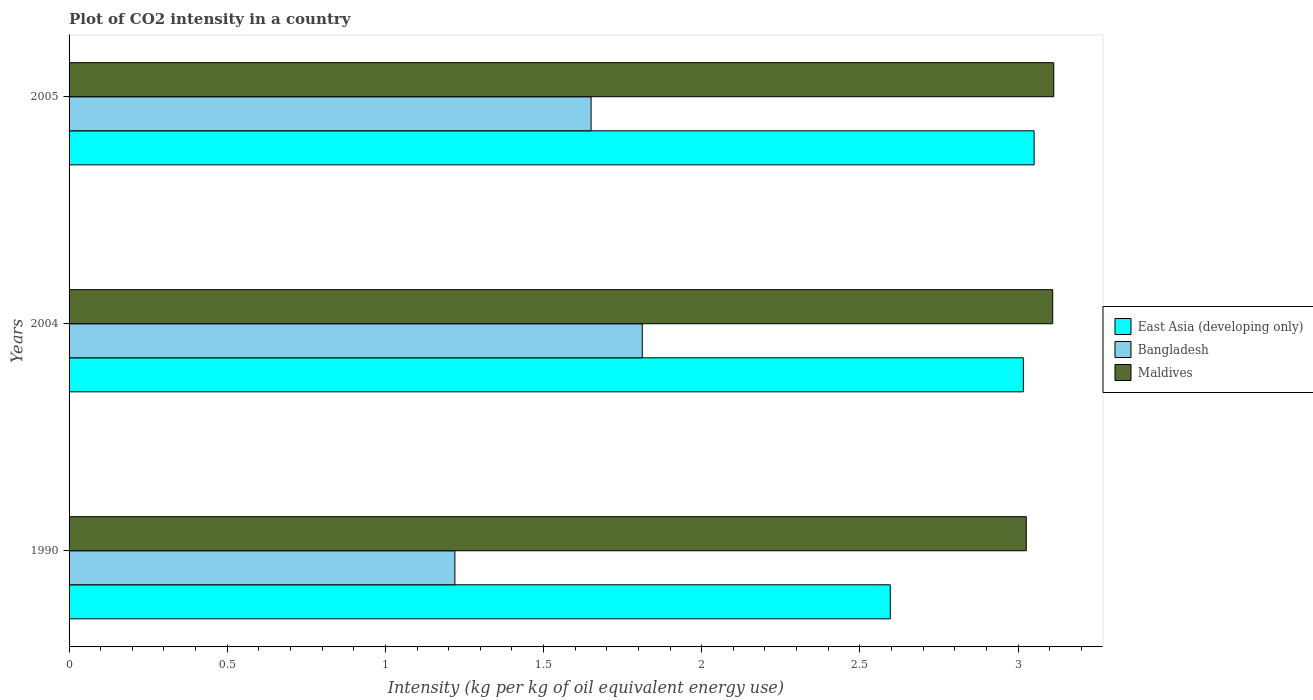How many different coloured bars are there?
Your response must be concise. 3. How many groups of bars are there?
Your answer should be compact. 3. How many bars are there on the 2nd tick from the top?
Ensure brevity in your answer.  3. How many bars are there on the 3rd tick from the bottom?
Ensure brevity in your answer.  3. In how many cases, is the number of bars for a given year not equal to the number of legend labels?
Your answer should be very brief. 0. What is the CO2 intensity in in Maldives in 2005?
Offer a very short reply. 3.11. Across all years, what is the maximum CO2 intensity in in East Asia (developing only)?
Your response must be concise. 3.05. Across all years, what is the minimum CO2 intensity in in Bangladesh?
Provide a short and direct response. 1.22. In which year was the CO2 intensity in in Maldives maximum?
Make the answer very short. 2005. What is the total CO2 intensity in in Maldives in the graph?
Keep it short and to the point. 9.25. What is the difference between the CO2 intensity in in East Asia (developing only) in 1990 and that in 2004?
Ensure brevity in your answer.  -0.42. What is the difference between the CO2 intensity in in East Asia (developing only) in 1990 and the CO2 intensity in in Bangladesh in 2004?
Provide a short and direct response. 0.78. What is the average CO2 intensity in in Maldives per year?
Ensure brevity in your answer.  3.08. In the year 2005, what is the difference between the CO2 intensity in in Bangladesh and CO2 intensity in in Maldives?
Give a very brief answer. -1.46. What is the ratio of the CO2 intensity in in Bangladesh in 1990 to that in 2004?
Make the answer very short. 0.67. Is the CO2 intensity in in East Asia (developing only) in 1990 less than that in 2004?
Your response must be concise. Yes. Is the difference between the CO2 intensity in in Bangladesh in 1990 and 2004 greater than the difference between the CO2 intensity in in Maldives in 1990 and 2004?
Offer a very short reply. No. What is the difference between the highest and the second highest CO2 intensity in in Bangladesh?
Provide a succinct answer. 0.16. What is the difference between the highest and the lowest CO2 intensity in in Bangladesh?
Give a very brief answer. 0.59. In how many years, is the CO2 intensity in in Maldives greater than the average CO2 intensity in in Maldives taken over all years?
Keep it short and to the point. 2. Is it the case that in every year, the sum of the CO2 intensity in in Maldives and CO2 intensity in in East Asia (developing only) is greater than the CO2 intensity in in Bangladesh?
Make the answer very short. Yes. How many years are there in the graph?
Your answer should be very brief. 3. Does the graph contain any zero values?
Your answer should be compact. No. How are the legend labels stacked?
Keep it short and to the point. Vertical. What is the title of the graph?
Offer a terse response. Plot of CO2 intensity in a country. What is the label or title of the X-axis?
Offer a very short reply. Intensity (kg per kg of oil equivalent energy use). What is the label or title of the Y-axis?
Your answer should be compact. Years. What is the Intensity (kg per kg of oil equivalent energy use) in East Asia (developing only) in 1990?
Provide a short and direct response. 2.6. What is the Intensity (kg per kg of oil equivalent energy use) in Bangladesh in 1990?
Give a very brief answer. 1.22. What is the Intensity (kg per kg of oil equivalent energy use) of Maldives in 1990?
Ensure brevity in your answer.  3.03. What is the Intensity (kg per kg of oil equivalent energy use) in East Asia (developing only) in 2004?
Offer a very short reply. 3.02. What is the Intensity (kg per kg of oil equivalent energy use) in Bangladesh in 2004?
Keep it short and to the point. 1.81. What is the Intensity (kg per kg of oil equivalent energy use) in Maldives in 2004?
Your answer should be compact. 3.11. What is the Intensity (kg per kg of oil equivalent energy use) in East Asia (developing only) in 2005?
Give a very brief answer. 3.05. What is the Intensity (kg per kg of oil equivalent energy use) in Bangladesh in 2005?
Your answer should be very brief. 1.65. What is the Intensity (kg per kg of oil equivalent energy use) in Maldives in 2005?
Offer a terse response. 3.11. Across all years, what is the maximum Intensity (kg per kg of oil equivalent energy use) in East Asia (developing only)?
Keep it short and to the point. 3.05. Across all years, what is the maximum Intensity (kg per kg of oil equivalent energy use) of Bangladesh?
Provide a succinct answer. 1.81. Across all years, what is the maximum Intensity (kg per kg of oil equivalent energy use) in Maldives?
Your answer should be very brief. 3.11. Across all years, what is the minimum Intensity (kg per kg of oil equivalent energy use) in East Asia (developing only)?
Offer a very short reply. 2.6. Across all years, what is the minimum Intensity (kg per kg of oil equivalent energy use) in Bangladesh?
Your answer should be compact. 1.22. Across all years, what is the minimum Intensity (kg per kg of oil equivalent energy use) in Maldives?
Your answer should be compact. 3.03. What is the total Intensity (kg per kg of oil equivalent energy use) of East Asia (developing only) in the graph?
Make the answer very short. 8.66. What is the total Intensity (kg per kg of oil equivalent energy use) in Bangladesh in the graph?
Provide a succinct answer. 4.68. What is the total Intensity (kg per kg of oil equivalent energy use) in Maldives in the graph?
Keep it short and to the point. 9.25. What is the difference between the Intensity (kg per kg of oil equivalent energy use) of East Asia (developing only) in 1990 and that in 2004?
Your answer should be compact. -0.42. What is the difference between the Intensity (kg per kg of oil equivalent energy use) in Bangladesh in 1990 and that in 2004?
Your answer should be very brief. -0.59. What is the difference between the Intensity (kg per kg of oil equivalent energy use) of Maldives in 1990 and that in 2004?
Your answer should be compact. -0.08. What is the difference between the Intensity (kg per kg of oil equivalent energy use) in East Asia (developing only) in 1990 and that in 2005?
Keep it short and to the point. -0.45. What is the difference between the Intensity (kg per kg of oil equivalent energy use) of Bangladesh in 1990 and that in 2005?
Ensure brevity in your answer.  -0.43. What is the difference between the Intensity (kg per kg of oil equivalent energy use) of Maldives in 1990 and that in 2005?
Make the answer very short. -0.09. What is the difference between the Intensity (kg per kg of oil equivalent energy use) of East Asia (developing only) in 2004 and that in 2005?
Your answer should be compact. -0.03. What is the difference between the Intensity (kg per kg of oil equivalent energy use) of Bangladesh in 2004 and that in 2005?
Offer a very short reply. 0.16. What is the difference between the Intensity (kg per kg of oil equivalent energy use) in Maldives in 2004 and that in 2005?
Offer a terse response. -0. What is the difference between the Intensity (kg per kg of oil equivalent energy use) in East Asia (developing only) in 1990 and the Intensity (kg per kg of oil equivalent energy use) in Bangladesh in 2004?
Ensure brevity in your answer.  0.78. What is the difference between the Intensity (kg per kg of oil equivalent energy use) in East Asia (developing only) in 1990 and the Intensity (kg per kg of oil equivalent energy use) in Maldives in 2004?
Offer a very short reply. -0.51. What is the difference between the Intensity (kg per kg of oil equivalent energy use) in Bangladesh in 1990 and the Intensity (kg per kg of oil equivalent energy use) in Maldives in 2004?
Your answer should be very brief. -1.89. What is the difference between the Intensity (kg per kg of oil equivalent energy use) in East Asia (developing only) in 1990 and the Intensity (kg per kg of oil equivalent energy use) in Bangladesh in 2005?
Provide a short and direct response. 0.95. What is the difference between the Intensity (kg per kg of oil equivalent energy use) of East Asia (developing only) in 1990 and the Intensity (kg per kg of oil equivalent energy use) of Maldives in 2005?
Give a very brief answer. -0.52. What is the difference between the Intensity (kg per kg of oil equivalent energy use) in Bangladesh in 1990 and the Intensity (kg per kg of oil equivalent energy use) in Maldives in 2005?
Give a very brief answer. -1.89. What is the difference between the Intensity (kg per kg of oil equivalent energy use) in East Asia (developing only) in 2004 and the Intensity (kg per kg of oil equivalent energy use) in Bangladesh in 2005?
Offer a very short reply. 1.37. What is the difference between the Intensity (kg per kg of oil equivalent energy use) in East Asia (developing only) in 2004 and the Intensity (kg per kg of oil equivalent energy use) in Maldives in 2005?
Your response must be concise. -0.1. What is the difference between the Intensity (kg per kg of oil equivalent energy use) of Bangladesh in 2004 and the Intensity (kg per kg of oil equivalent energy use) of Maldives in 2005?
Your answer should be compact. -1.3. What is the average Intensity (kg per kg of oil equivalent energy use) in East Asia (developing only) per year?
Provide a short and direct response. 2.89. What is the average Intensity (kg per kg of oil equivalent energy use) in Bangladesh per year?
Provide a succinct answer. 1.56. What is the average Intensity (kg per kg of oil equivalent energy use) in Maldives per year?
Your answer should be compact. 3.08. In the year 1990, what is the difference between the Intensity (kg per kg of oil equivalent energy use) of East Asia (developing only) and Intensity (kg per kg of oil equivalent energy use) of Bangladesh?
Provide a succinct answer. 1.38. In the year 1990, what is the difference between the Intensity (kg per kg of oil equivalent energy use) in East Asia (developing only) and Intensity (kg per kg of oil equivalent energy use) in Maldives?
Provide a short and direct response. -0.43. In the year 1990, what is the difference between the Intensity (kg per kg of oil equivalent energy use) in Bangladesh and Intensity (kg per kg of oil equivalent energy use) in Maldives?
Ensure brevity in your answer.  -1.81. In the year 2004, what is the difference between the Intensity (kg per kg of oil equivalent energy use) of East Asia (developing only) and Intensity (kg per kg of oil equivalent energy use) of Bangladesh?
Your answer should be compact. 1.2. In the year 2004, what is the difference between the Intensity (kg per kg of oil equivalent energy use) in East Asia (developing only) and Intensity (kg per kg of oil equivalent energy use) in Maldives?
Your answer should be compact. -0.09. In the year 2004, what is the difference between the Intensity (kg per kg of oil equivalent energy use) of Bangladesh and Intensity (kg per kg of oil equivalent energy use) of Maldives?
Your answer should be very brief. -1.3. In the year 2005, what is the difference between the Intensity (kg per kg of oil equivalent energy use) in East Asia (developing only) and Intensity (kg per kg of oil equivalent energy use) in Bangladesh?
Your answer should be compact. 1.4. In the year 2005, what is the difference between the Intensity (kg per kg of oil equivalent energy use) in East Asia (developing only) and Intensity (kg per kg of oil equivalent energy use) in Maldives?
Your answer should be compact. -0.06. In the year 2005, what is the difference between the Intensity (kg per kg of oil equivalent energy use) in Bangladesh and Intensity (kg per kg of oil equivalent energy use) in Maldives?
Keep it short and to the point. -1.46. What is the ratio of the Intensity (kg per kg of oil equivalent energy use) of East Asia (developing only) in 1990 to that in 2004?
Provide a short and direct response. 0.86. What is the ratio of the Intensity (kg per kg of oil equivalent energy use) of Bangladesh in 1990 to that in 2004?
Keep it short and to the point. 0.67. What is the ratio of the Intensity (kg per kg of oil equivalent energy use) in Maldives in 1990 to that in 2004?
Ensure brevity in your answer.  0.97. What is the ratio of the Intensity (kg per kg of oil equivalent energy use) in East Asia (developing only) in 1990 to that in 2005?
Your response must be concise. 0.85. What is the ratio of the Intensity (kg per kg of oil equivalent energy use) of Bangladesh in 1990 to that in 2005?
Provide a short and direct response. 0.74. What is the ratio of the Intensity (kg per kg of oil equivalent energy use) of Maldives in 1990 to that in 2005?
Offer a very short reply. 0.97. What is the ratio of the Intensity (kg per kg of oil equivalent energy use) of Bangladesh in 2004 to that in 2005?
Offer a very short reply. 1.1. What is the difference between the highest and the second highest Intensity (kg per kg of oil equivalent energy use) in East Asia (developing only)?
Your answer should be very brief. 0.03. What is the difference between the highest and the second highest Intensity (kg per kg of oil equivalent energy use) of Bangladesh?
Give a very brief answer. 0.16. What is the difference between the highest and the second highest Intensity (kg per kg of oil equivalent energy use) of Maldives?
Provide a short and direct response. 0. What is the difference between the highest and the lowest Intensity (kg per kg of oil equivalent energy use) in East Asia (developing only)?
Offer a terse response. 0.45. What is the difference between the highest and the lowest Intensity (kg per kg of oil equivalent energy use) of Bangladesh?
Give a very brief answer. 0.59. What is the difference between the highest and the lowest Intensity (kg per kg of oil equivalent energy use) of Maldives?
Ensure brevity in your answer.  0.09. 